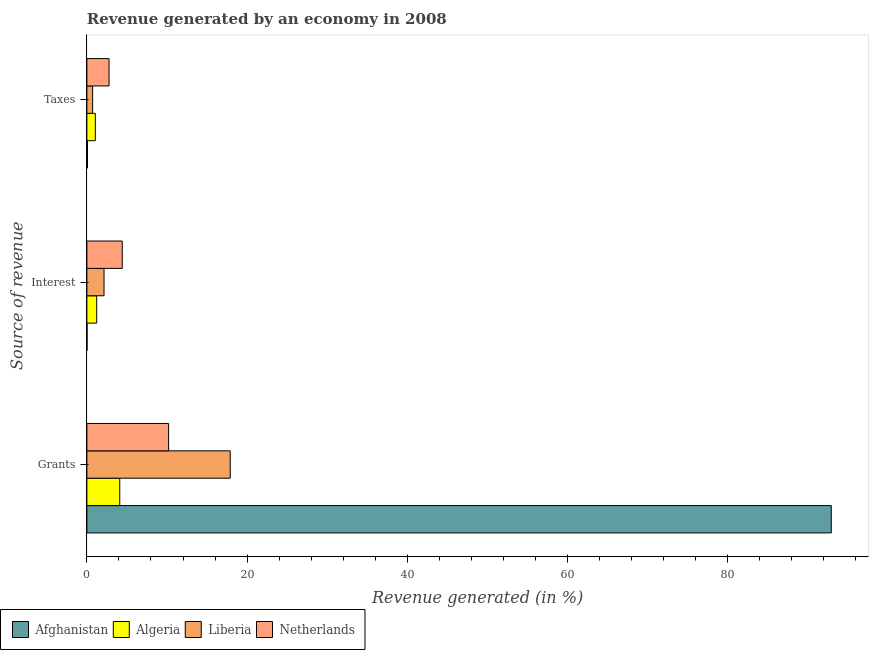How many different coloured bars are there?
Give a very brief answer. 4. How many groups of bars are there?
Your answer should be compact. 3. How many bars are there on the 1st tick from the top?
Keep it short and to the point. 4. How many bars are there on the 1st tick from the bottom?
Your response must be concise. 4. What is the label of the 1st group of bars from the top?
Provide a succinct answer. Taxes. What is the percentage of revenue generated by grants in Afghanistan?
Offer a very short reply. 92.92. Across all countries, what is the maximum percentage of revenue generated by taxes?
Your answer should be compact. 2.77. Across all countries, what is the minimum percentage of revenue generated by taxes?
Offer a terse response. 0.08. In which country was the percentage of revenue generated by grants maximum?
Offer a terse response. Afghanistan. In which country was the percentage of revenue generated by grants minimum?
Keep it short and to the point. Algeria. What is the total percentage of revenue generated by grants in the graph?
Your answer should be compact. 125.12. What is the difference between the percentage of revenue generated by taxes in Liberia and that in Afghanistan?
Make the answer very short. 0.64. What is the difference between the percentage of revenue generated by grants in Netherlands and the percentage of revenue generated by interest in Liberia?
Offer a very short reply. 8.06. What is the average percentage of revenue generated by grants per country?
Keep it short and to the point. 31.28. What is the difference between the percentage of revenue generated by grants and percentage of revenue generated by taxes in Algeria?
Your answer should be compact. 3.05. In how many countries, is the percentage of revenue generated by interest greater than 40 %?
Your response must be concise. 0. What is the ratio of the percentage of revenue generated by interest in Algeria to that in Liberia?
Your answer should be compact. 0.57. What is the difference between the highest and the second highest percentage of revenue generated by grants?
Your answer should be very brief. 75.02. What is the difference between the highest and the lowest percentage of revenue generated by grants?
Offer a terse response. 88.81. In how many countries, is the percentage of revenue generated by interest greater than the average percentage of revenue generated by interest taken over all countries?
Provide a succinct answer. 2. What does the 4th bar from the top in Interest represents?
Offer a terse response. Afghanistan. What does the 4th bar from the bottom in Grants represents?
Offer a very short reply. Netherlands. What is the difference between two consecutive major ticks on the X-axis?
Provide a short and direct response. 20. Are the values on the major ticks of X-axis written in scientific E-notation?
Ensure brevity in your answer.  No. Where does the legend appear in the graph?
Your answer should be compact. Bottom left. How many legend labels are there?
Your answer should be compact. 4. How are the legend labels stacked?
Keep it short and to the point. Horizontal. What is the title of the graph?
Give a very brief answer. Revenue generated by an economy in 2008. What is the label or title of the X-axis?
Provide a short and direct response. Revenue generated (in %). What is the label or title of the Y-axis?
Keep it short and to the point. Source of revenue. What is the Revenue generated (in %) in Afghanistan in Grants?
Keep it short and to the point. 92.92. What is the Revenue generated (in %) of Algeria in Grants?
Offer a very short reply. 4.1. What is the Revenue generated (in %) of Liberia in Grants?
Your answer should be compact. 17.9. What is the Revenue generated (in %) of Netherlands in Grants?
Your answer should be compact. 10.2. What is the Revenue generated (in %) of Afghanistan in Interest?
Ensure brevity in your answer.  0.02. What is the Revenue generated (in %) of Algeria in Interest?
Offer a very short reply. 1.23. What is the Revenue generated (in %) in Liberia in Interest?
Offer a very short reply. 2.14. What is the Revenue generated (in %) in Netherlands in Interest?
Keep it short and to the point. 4.42. What is the Revenue generated (in %) of Afghanistan in Taxes?
Your answer should be compact. 0.08. What is the Revenue generated (in %) of Algeria in Taxes?
Provide a short and direct response. 1.05. What is the Revenue generated (in %) of Liberia in Taxes?
Your answer should be compact. 0.72. What is the Revenue generated (in %) in Netherlands in Taxes?
Your answer should be very brief. 2.77. Across all Source of revenue, what is the maximum Revenue generated (in %) in Afghanistan?
Your answer should be compact. 92.92. Across all Source of revenue, what is the maximum Revenue generated (in %) of Algeria?
Your answer should be very brief. 4.1. Across all Source of revenue, what is the maximum Revenue generated (in %) in Liberia?
Keep it short and to the point. 17.9. Across all Source of revenue, what is the maximum Revenue generated (in %) of Netherlands?
Ensure brevity in your answer.  10.2. Across all Source of revenue, what is the minimum Revenue generated (in %) of Afghanistan?
Offer a very short reply. 0.02. Across all Source of revenue, what is the minimum Revenue generated (in %) of Algeria?
Your answer should be very brief. 1.05. Across all Source of revenue, what is the minimum Revenue generated (in %) of Liberia?
Provide a short and direct response. 0.72. Across all Source of revenue, what is the minimum Revenue generated (in %) in Netherlands?
Provide a short and direct response. 2.77. What is the total Revenue generated (in %) of Afghanistan in the graph?
Provide a succinct answer. 93.01. What is the total Revenue generated (in %) in Algeria in the graph?
Your answer should be compact. 6.39. What is the total Revenue generated (in %) in Liberia in the graph?
Your answer should be very brief. 20.75. What is the total Revenue generated (in %) in Netherlands in the graph?
Your answer should be compact. 17.38. What is the difference between the Revenue generated (in %) of Afghanistan in Grants and that in Interest?
Provide a short and direct response. 92.89. What is the difference between the Revenue generated (in %) of Algeria in Grants and that in Interest?
Offer a very short reply. 2.88. What is the difference between the Revenue generated (in %) in Liberia in Grants and that in Interest?
Your answer should be very brief. 15.76. What is the difference between the Revenue generated (in %) of Netherlands in Grants and that in Interest?
Provide a succinct answer. 5.78. What is the difference between the Revenue generated (in %) of Afghanistan in Grants and that in Taxes?
Give a very brief answer. 92.84. What is the difference between the Revenue generated (in %) in Algeria in Grants and that in Taxes?
Offer a very short reply. 3.05. What is the difference between the Revenue generated (in %) of Liberia in Grants and that in Taxes?
Make the answer very short. 17.18. What is the difference between the Revenue generated (in %) in Netherlands in Grants and that in Taxes?
Your answer should be compact. 7.44. What is the difference between the Revenue generated (in %) of Afghanistan in Interest and that in Taxes?
Offer a terse response. -0.05. What is the difference between the Revenue generated (in %) in Algeria in Interest and that in Taxes?
Your response must be concise. 0.17. What is the difference between the Revenue generated (in %) in Liberia in Interest and that in Taxes?
Your response must be concise. 1.43. What is the difference between the Revenue generated (in %) of Netherlands in Interest and that in Taxes?
Offer a terse response. 1.65. What is the difference between the Revenue generated (in %) in Afghanistan in Grants and the Revenue generated (in %) in Algeria in Interest?
Make the answer very short. 91.69. What is the difference between the Revenue generated (in %) of Afghanistan in Grants and the Revenue generated (in %) of Liberia in Interest?
Ensure brevity in your answer.  90.78. What is the difference between the Revenue generated (in %) of Afghanistan in Grants and the Revenue generated (in %) of Netherlands in Interest?
Offer a very short reply. 88.5. What is the difference between the Revenue generated (in %) in Algeria in Grants and the Revenue generated (in %) in Liberia in Interest?
Provide a short and direct response. 1.96. What is the difference between the Revenue generated (in %) in Algeria in Grants and the Revenue generated (in %) in Netherlands in Interest?
Your response must be concise. -0.31. What is the difference between the Revenue generated (in %) in Liberia in Grants and the Revenue generated (in %) in Netherlands in Interest?
Give a very brief answer. 13.48. What is the difference between the Revenue generated (in %) in Afghanistan in Grants and the Revenue generated (in %) in Algeria in Taxes?
Offer a terse response. 91.86. What is the difference between the Revenue generated (in %) of Afghanistan in Grants and the Revenue generated (in %) of Liberia in Taxes?
Keep it short and to the point. 92.2. What is the difference between the Revenue generated (in %) in Afghanistan in Grants and the Revenue generated (in %) in Netherlands in Taxes?
Make the answer very short. 90.15. What is the difference between the Revenue generated (in %) of Algeria in Grants and the Revenue generated (in %) of Liberia in Taxes?
Offer a very short reply. 3.39. What is the difference between the Revenue generated (in %) of Algeria in Grants and the Revenue generated (in %) of Netherlands in Taxes?
Make the answer very short. 1.34. What is the difference between the Revenue generated (in %) of Liberia in Grants and the Revenue generated (in %) of Netherlands in Taxes?
Offer a terse response. 15.13. What is the difference between the Revenue generated (in %) of Afghanistan in Interest and the Revenue generated (in %) of Algeria in Taxes?
Your response must be concise. -1.03. What is the difference between the Revenue generated (in %) of Afghanistan in Interest and the Revenue generated (in %) of Liberia in Taxes?
Ensure brevity in your answer.  -0.69. What is the difference between the Revenue generated (in %) of Afghanistan in Interest and the Revenue generated (in %) of Netherlands in Taxes?
Offer a terse response. -2.74. What is the difference between the Revenue generated (in %) of Algeria in Interest and the Revenue generated (in %) of Liberia in Taxes?
Your response must be concise. 0.51. What is the difference between the Revenue generated (in %) of Algeria in Interest and the Revenue generated (in %) of Netherlands in Taxes?
Keep it short and to the point. -1.54. What is the difference between the Revenue generated (in %) of Liberia in Interest and the Revenue generated (in %) of Netherlands in Taxes?
Offer a terse response. -0.62. What is the average Revenue generated (in %) in Afghanistan per Source of revenue?
Offer a terse response. 31. What is the average Revenue generated (in %) in Algeria per Source of revenue?
Your response must be concise. 2.13. What is the average Revenue generated (in %) in Liberia per Source of revenue?
Provide a succinct answer. 6.92. What is the average Revenue generated (in %) of Netherlands per Source of revenue?
Provide a succinct answer. 5.79. What is the difference between the Revenue generated (in %) in Afghanistan and Revenue generated (in %) in Algeria in Grants?
Your response must be concise. 88.81. What is the difference between the Revenue generated (in %) in Afghanistan and Revenue generated (in %) in Liberia in Grants?
Your answer should be compact. 75.02. What is the difference between the Revenue generated (in %) of Afghanistan and Revenue generated (in %) of Netherlands in Grants?
Offer a very short reply. 82.72. What is the difference between the Revenue generated (in %) of Algeria and Revenue generated (in %) of Liberia in Grants?
Offer a very short reply. -13.79. What is the difference between the Revenue generated (in %) in Algeria and Revenue generated (in %) in Netherlands in Grants?
Make the answer very short. -6.1. What is the difference between the Revenue generated (in %) of Liberia and Revenue generated (in %) of Netherlands in Grants?
Offer a very short reply. 7.7. What is the difference between the Revenue generated (in %) of Afghanistan and Revenue generated (in %) of Algeria in Interest?
Provide a short and direct response. -1.2. What is the difference between the Revenue generated (in %) of Afghanistan and Revenue generated (in %) of Liberia in Interest?
Make the answer very short. -2.12. What is the difference between the Revenue generated (in %) of Afghanistan and Revenue generated (in %) of Netherlands in Interest?
Your answer should be compact. -4.39. What is the difference between the Revenue generated (in %) in Algeria and Revenue generated (in %) in Liberia in Interest?
Offer a terse response. -0.91. What is the difference between the Revenue generated (in %) in Algeria and Revenue generated (in %) in Netherlands in Interest?
Keep it short and to the point. -3.19. What is the difference between the Revenue generated (in %) of Liberia and Revenue generated (in %) of Netherlands in Interest?
Your answer should be compact. -2.27. What is the difference between the Revenue generated (in %) of Afghanistan and Revenue generated (in %) of Algeria in Taxes?
Keep it short and to the point. -0.98. What is the difference between the Revenue generated (in %) in Afghanistan and Revenue generated (in %) in Liberia in Taxes?
Offer a very short reply. -0.64. What is the difference between the Revenue generated (in %) in Afghanistan and Revenue generated (in %) in Netherlands in Taxes?
Your answer should be very brief. -2.69. What is the difference between the Revenue generated (in %) in Algeria and Revenue generated (in %) in Liberia in Taxes?
Your answer should be compact. 0.34. What is the difference between the Revenue generated (in %) of Algeria and Revenue generated (in %) of Netherlands in Taxes?
Your answer should be very brief. -1.71. What is the difference between the Revenue generated (in %) of Liberia and Revenue generated (in %) of Netherlands in Taxes?
Offer a very short reply. -2.05. What is the ratio of the Revenue generated (in %) of Afghanistan in Grants to that in Interest?
Your response must be concise. 4085.31. What is the ratio of the Revenue generated (in %) of Algeria in Grants to that in Interest?
Offer a very short reply. 3.35. What is the ratio of the Revenue generated (in %) of Liberia in Grants to that in Interest?
Your answer should be very brief. 8.36. What is the ratio of the Revenue generated (in %) in Netherlands in Grants to that in Interest?
Make the answer very short. 2.31. What is the ratio of the Revenue generated (in %) of Afghanistan in Grants to that in Taxes?
Ensure brevity in your answer.  1237.37. What is the ratio of the Revenue generated (in %) of Algeria in Grants to that in Taxes?
Your answer should be compact. 3.89. What is the ratio of the Revenue generated (in %) in Liberia in Grants to that in Taxes?
Ensure brevity in your answer.  25.03. What is the ratio of the Revenue generated (in %) in Netherlands in Grants to that in Taxes?
Ensure brevity in your answer.  3.69. What is the ratio of the Revenue generated (in %) in Afghanistan in Interest to that in Taxes?
Your answer should be very brief. 0.3. What is the ratio of the Revenue generated (in %) in Algeria in Interest to that in Taxes?
Ensure brevity in your answer.  1.16. What is the ratio of the Revenue generated (in %) in Liberia in Interest to that in Taxes?
Offer a very short reply. 2.99. What is the ratio of the Revenue generated (in %) of Netherlands in Interest to that in Taxes?
Offer a very short reply. 1.6. What is the difference between the highest and the second highest Revenue generated (in %) in Afghanistan?
Offer a very short reply. 92.84. What is the difference between the highest and the second highest Revenue generated (in %) of Algeria?
Your answer should be compact. 2.88. What is the difference between the highest and the second highest Revenue generated (in %) in Liberia?
Provide a succinct answer. 15.76. What is the difference between the highest and the second highest Revenue generated (in %) in Netherlands?
Your answer should be compact. 5.78. What is the difference between the highest and the lowest Revenue generated (in %) in Afghanistan?
Make the answer very short. 92.89. What is the difference between the highest and the lowest Revenue generated (in %) in Algeria?
Give a very brief answer. 3.05. What is the difference between the highest and the lowest Revenue generated (in %) of Liberia?
Provide a succinct answer. 17.18. What is the difference between the highest and the lowest Revenue generated (in %) in Netherlands?
Your answer should be compact. 7.44. 